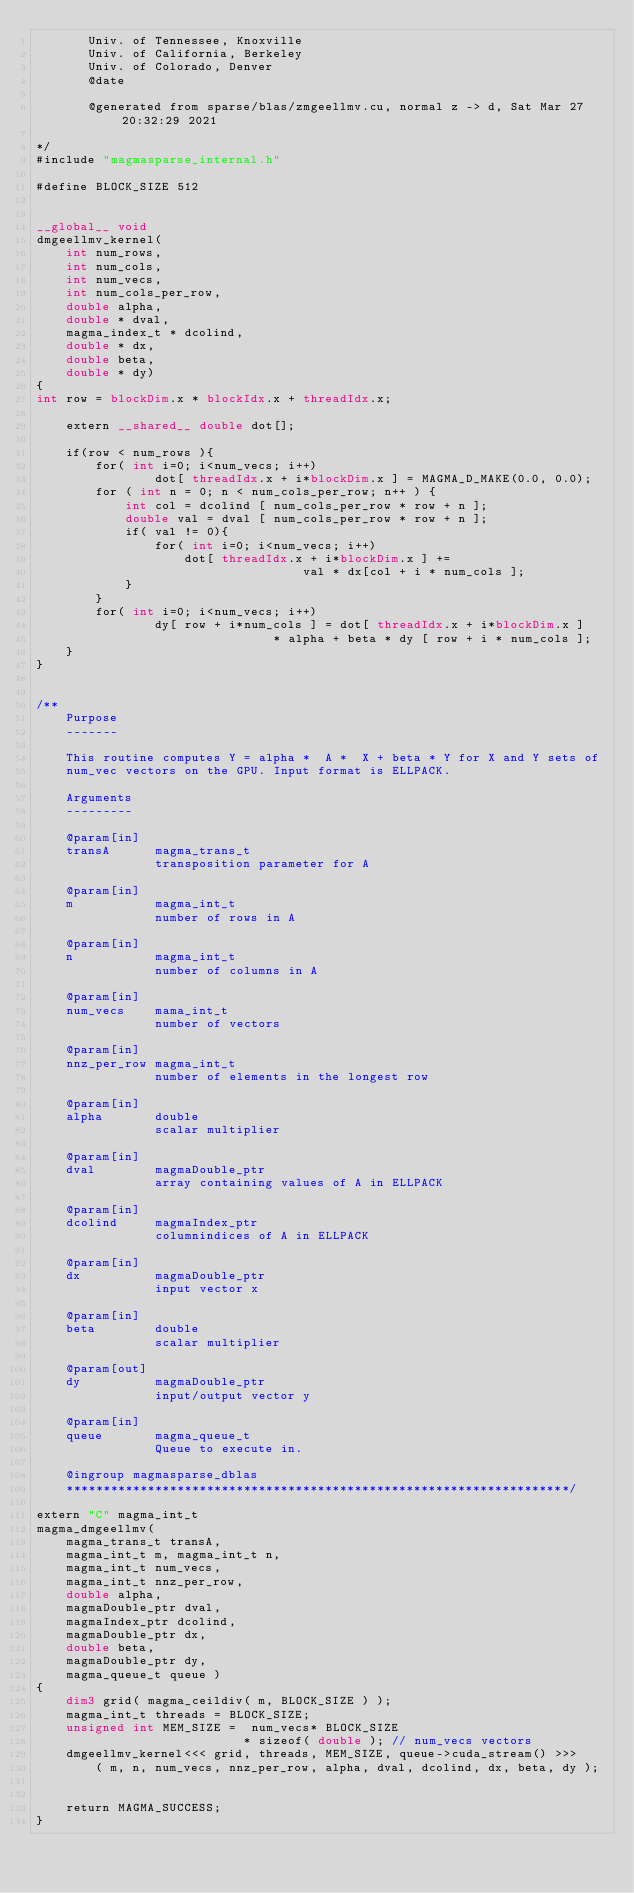<code> <loc_0><loc_0><loc_500><loc_500><_Cuda_>       Univ. of Tennessee, Knoxville
       Univ. of California, Berkeley
       Univ. of Colorado, Denver
       @date

       @generated from sparse/blas/zmgeellmv.cu, normal z -> d, Sat Mar 27 20:32:29 2021

*/
#include "magmasparse_internal.h"

#define BLOCK_SIZE 512


__global__ void 
dmgeellmv_kernel( 
    int num_rows, 
    int num_cols,
    int num_vecs,
    int num_cols_per_row,
    double alpha, 
    double * dval, 
    magma_index_t * dcolind,
    double * dx,
    double beta, 
    double * dy)
{
int row = blockDim.x * blockIdx.x + threadIdx.x;

    extern __shared__ double dot[];

    if(row < num_rows ){
        for( int i=0; i<num_vecs; i++)
                dot[ threadIdx.x + i*blockDim.x ] = MAGMA_D_MAKE(0.0, 0.0);
        for ( int n = 0; n < num_cols_per_row; n++ ) {
            int col = dcolind [ num_cols_per_row * row + n ];
            double val = dval [ num_cols_per_row * row + n ];
            if( val != 0){
                for( int i=0; i<num_vecs; i++)
                    dot[ threadIdx.x + i*blockDim.x ] += 
                                    val * dx[col + i * num_cols ];
            }
        }
        for( int i=0; i<num_vecs; i++)
                dy[ row + i*num_cols ] = dot[ threadIdx.x + i*blockDim.x ] 
                                * alpha + beta * dy [ row + i * num_cols ];
    }
}


/**
    Purpose
    -------
    
    This routine computes Y = alpha *  A *  X + beta * Y for X and Y sets of 
    num_vec vectors on the GPU. Input format is ELLPACK. 
    
    Arguments
    ---------

    @param[in]
    transA      magma_trans_t
                transposition parameter for A

    @param[in]
    m           magma_int_t
                number of rows in A

    @param[in]
    n           magma_int_t
                number of columns in A 
                              
    @param[in]
    num_vecs    mama_int_t
                number of vectors
                
    @param[in]
    nnz_per_row magma_int_t
                number of elements in the longest row 
                
    @param[in]
    alpha       double
                scalar multiplier

    @param[in]
    dval        magmaDouble_ptr
                array containing values of A in ELLPACK

    @param[in]
    dcolind     magmaIndex_ptr
                columnindices of A in ELLPACK

    @param[in]
    dx          magmaDouble_ptr
                input vector x

    @param[in]
    beta        double
                scalar multiplier

    @param[out]
    dy          magmaDouble_ptr
                input/output vector y

    @param[in]
    queue       magma_queue_t
                Queue to execute in.

    @ingroup magmasparse_dblas
    ********************************************************************/

extern "C" magma_int_t
magma_dmgeellmv(
    magma_trans_t transA,
    magma_int_t m, magma_int_t n,
    magma_int_t num_vecs,
    magma_int_t nnz_per_row,
    double alpha,
    magmaDouble_ptr dval,
    magmaIndex_ptr dcolind,
    magmaDouble_ptr dx,
    double beta,
    magmaDouble_ptr dy,
    magma_queue_t queue )
{
    dim3 grid( magma_ceildiv( m, BLOCK_SIZE ) );
    magma_int_t threads = BLOCK_SIZE;
    unsigned int MEM_SIZE =  num_vecs* BLOCK_SIZE 
                            * sizeof( double ); // num_vecs vectors 
    dmgeellmv_kernel<<< grid, threads, MEM_SIZE, queue->cuda_stream() >>>
        ( m, n, num_vecs, nnz_per_row, alpha, dval, dcolind, dx, beta, dy );


    return MAGMA_SUCCESS;
}
</code> 